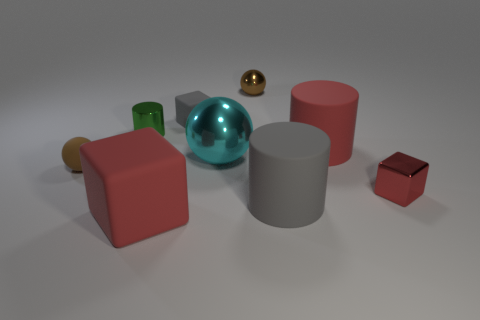What is the shape of the small metal object that is the same color as the rubber ball?
Provide a short and direct response. Sphere. What color is the shiny cube?
Give a very brief answer. Red. What is the material of the gray block?
Your answer should be compact. Rubber. The green metal thing that is the same size as the matte sphere is what shape?
Keep it short and to the point. Cylinder. Are there any cylinders that have the same color as the tiny rubber block?
Give a very brief answer. Yes. Does the tiny metallic cube have the same color as the cylinder on the left side of the gray cylinder?
Give a very brief answer. No. What is the color of the block behind the small block that is in front of the cyan thing?
Keep it short and to the point. Gray. Is there a small ball to the right of the red matte object that is to the right of the tiny metallic thing that is behind the green metal object?
Offer a terse response. No. What color is the big ball that is made of the same material as the small red object?
Your answer should be compact. Cyan. What number of tiny gray blocks have the same material as the cyan object?
Ensure brevity in your answer.  0. 